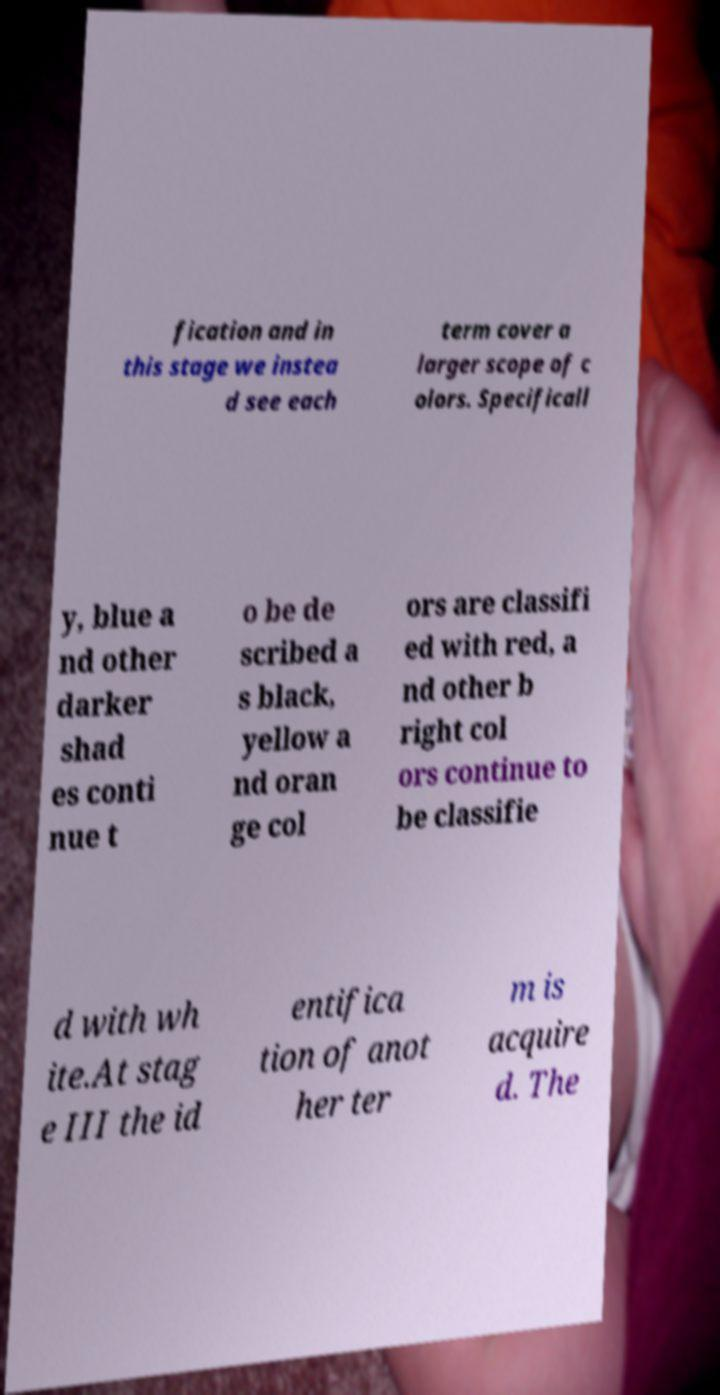Can you read and provide the text displayed in the image?This photo seems to have some interesting text. Can you extract and type it out for me? fication and in this stage we instea d see each term cover a larger scope of c olors. Specificall y, blue a nd other darker shad es conti nue t o be de scribed a s black, yellow a nd oran ge col ors are classifi ed with red, a nd other b right col ors continue to be classifie d with wh ite.At stag e III the id entifica tion of anot her ter m is acquire d. The 